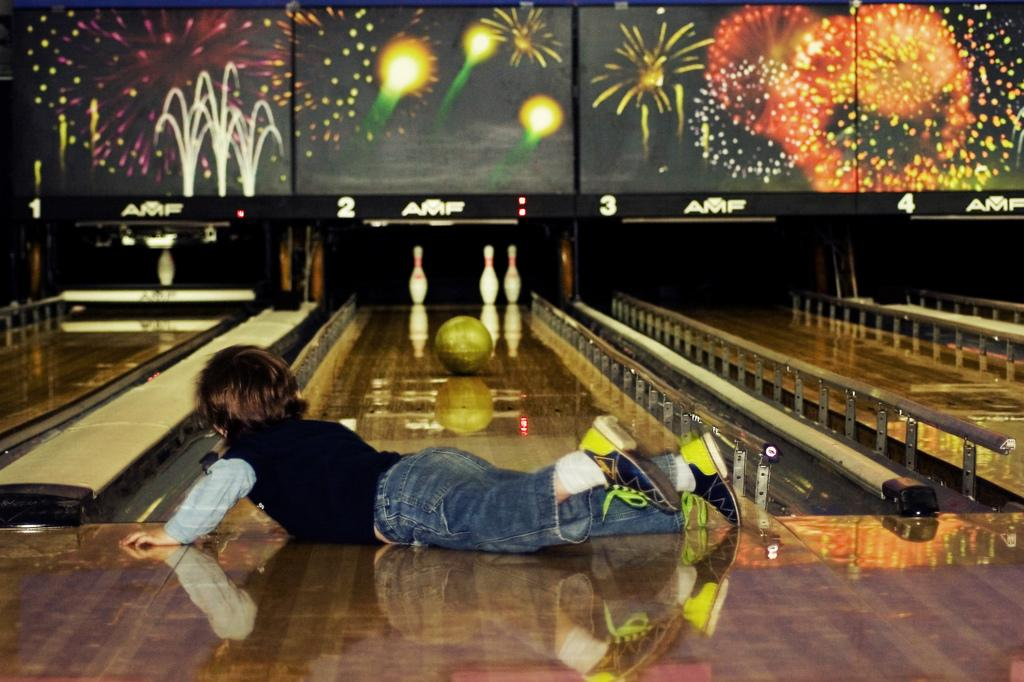What is the person in the image doing? The person is laying on the floor in the image. What object is in front of the person? There is a ball on a platform in front of the person. What is the ball about to do? The ball is about to hit the pins. What can be seen in the background of the image? There are screens visible in the background of the image. What type of cough medicine is the person taking in the image? There is no indication in the image that the person is taking any cough medicine. 